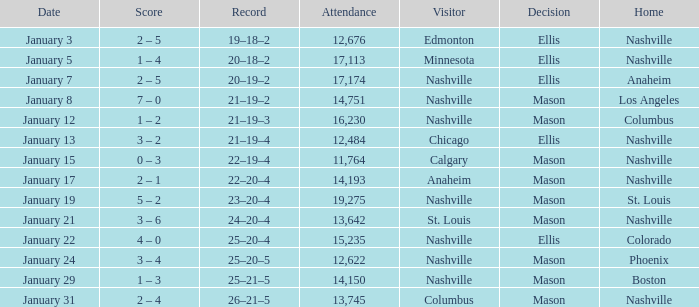On January 15, what was the most in attendance? 11764.0. 